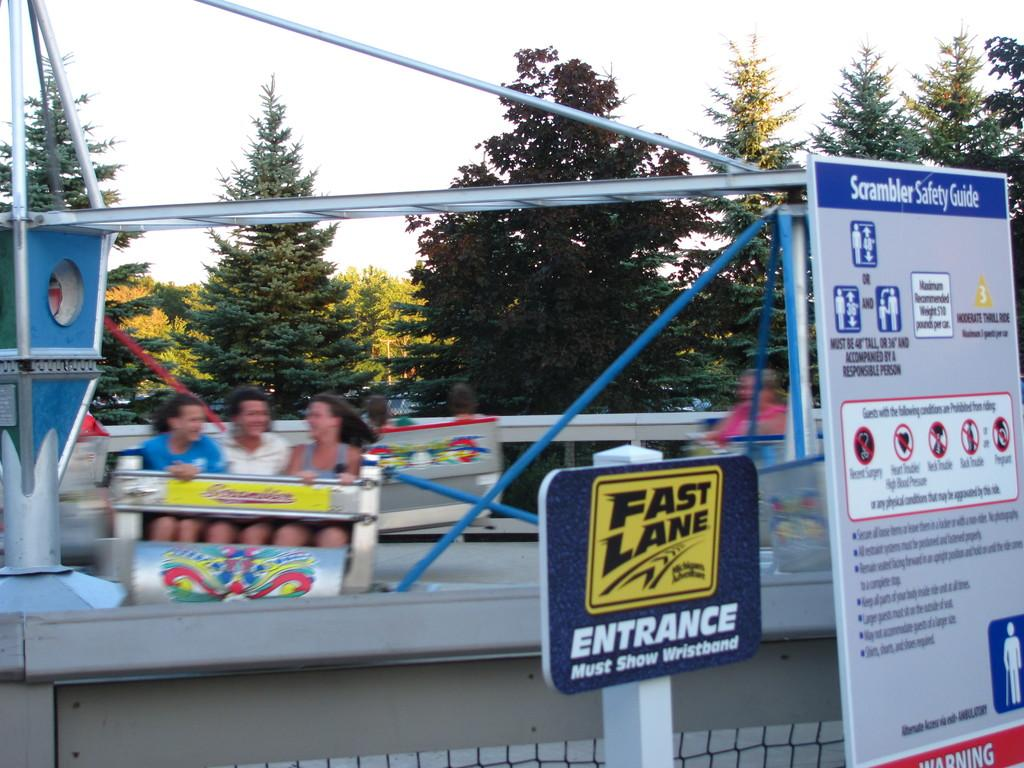What is the main subject of the image? There is an amusement ride in the image. What are the people in the image doing? The people are sitting on the amusement ride. What can be seen on the amusement ride besides the people? There are boards with text on the amusement ride. What is visible in the background of the image? The sky is visible in the background of the image. Can you tell me how many animals are on the amusement ride in the image? There are no animals present on the amusement ride in the image. What type of dime can be seen in the image? There is no dime visible in the image. 